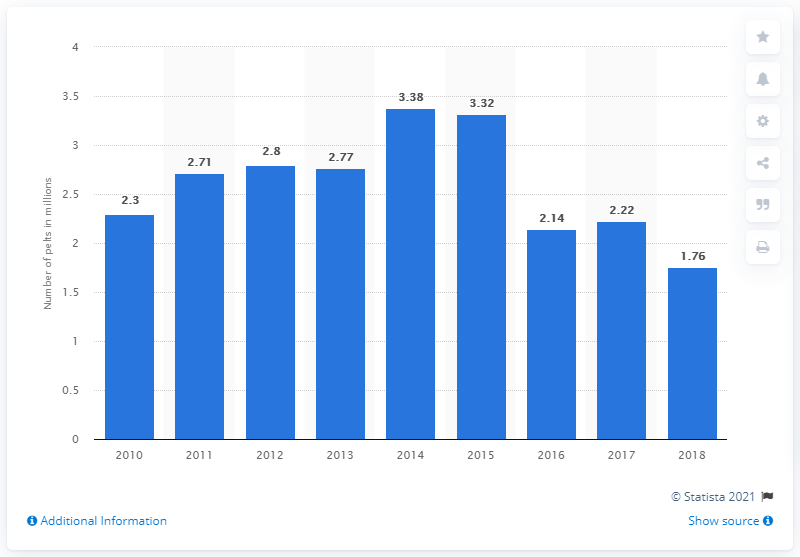Indicate a few pertinent items in this graphic. In 2010, it is estimated that 2.22 million mink pelts were produced in Canada. In 2018, the production of mink pelts in Canada totaled 1.76 million. 